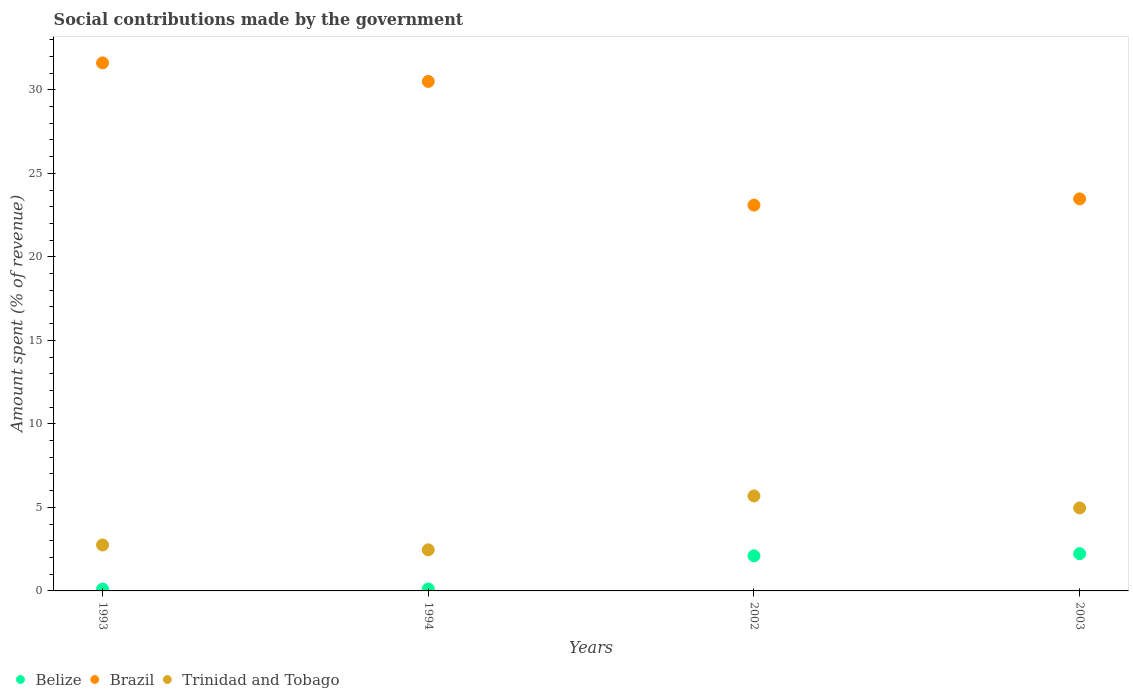Is the number of dotlines equal to the number of legend labels?
Make the answer very short. Yes. What is the amount spent (in %) on social contributions in Trinidad and Tobago in 2003?
Give a very brief answer. 4.97. Across all years, what is the maximum amount spent (in %) on social contributions in Brazil?
Keep it short and to the point. 31.61. Across all years, what is the minimum amount spent (in %) on social contributions in Belize?
Give a very brief answer. 0.11. What is the total amount spent (in %) on social contributions in Belize in the graph?
Offer a terse response. 4.56. What is the difference between the amount spent (in %) on social contributions in Brazil in 1993 and that in 2002?
Your answer should be compact. 8.51. What is the difference between the amount spent (in %) on social contributions in Belize in 1993 and the amount spent (in %) on social contributions in Trinidad and Tobago in 2003?
Offer a terse response. -4.85. What is the average amount spent (in %) on social contributions in Trinidad and Tobago per year?
Make the answer very short. 3.97. In the year 1993, what is the difference between the amount spent (in %) on social contributions in Belize and amount spent (in %) on social contributions in Trinidad and Tobago?
Offer a terse response. -2.64. What is the ratio of the amount spent (in %) on social contributions in Brazil in 2002 to that in 2003?
Your response must be concise. 0.98. What is the difference between the highest and the second highest amount spent (in %) on social contributions in Brazil?
Provide a short and direct response. 1.11. What is the difference between the highest and the lowest amount spent (in %) on social contributions in Brazil?
Offer a very short reply. 8.51. Is the sum of the amount spent (in %) on social contributions in Trinidad and Tobago in 1993 and 1994 greater than the maximum amount spent (in %) on social contributions in Brazil across all years?
Your answer should be very brief. No. Is it the case that in every year, the sum of the amount spent (in %) on social contributions in Trinidad and Tobago and amount spent (in %) on social contributions in Belize  is greater than the amount spent (in %) on social contributions in Brazil?
Your response must be concise. No. Does the amount spent (in %) on social contributions in Trinidad and Tobago monotonically increase over the years?
Offer a terse response. No. Is the amount spent (in %) on social contributions in Trinidad and Tobago strictly greater than the amount spent (in %) on social contributions in Brazil over the years?
Ensure brevity in your answer.  No. Is the amount spent (in %) on social contributions in Belize strictly less than the amount spent (in %) on social contributions in Brazil over the years?
Offer a terse response. Yes. How many dotlines are there?
Provide a succinct answer. 3. How many years are there in the graph?
Offer a very short reply. 4. What is the difference between two consecutive major ticks on the Y-axis?
Give a very brief answer. 5. Does the graph contain grids?
Ensure brevity in your answer.  No. How many legend labels are there?
Ensure brevity in your answer.  3. What is the title of the graph?
Ensure brevity in your answer.  Social contributions made by the government. What is the label or title of the Y-axis?
Offer a terse response. Amount spent (% of revenue). What is the Amount spent (% of revenue) in Belize in 1993?
Ensure brevity in your answer.  0.11. What is the Amount spent (% of revenue) of Brazil in 1993?
Your answer should be compact. 31.61. What is the Amount spent (% of revenue) of Trinidad and Tobago in 1993?
Give a very brief answer. 2.75. What is the Amount spent (% of revenue) in Belize in 1994?
Give a very brief answer. 0.12. What is the Amount spent (% of revenue) of Brazil in 1994?
Ensure brevity in your answer.  30.5. What is the Amount spent (% of revenue) in Trinidad and Tobago in 1994?
Provide a short and direct response. 2.46. What is the Amount spent (% of revenue) in Belize in 2002?
Offer a terse response. 2.1. What is the Amount spent (% of revenue) in Brazil in 2002?
Offer a terse response. 23.1. What is the Amount spent (% of revenue) in Trinidad and Tobago in 2002?
Ensure brevity in your answer.  5.69. What is the Amount spent (% of revenue) in Belize in 2003?
Ensure brevity in your answer.  2.23. What is the Amount spent (% of revenue) in Brazil in 2003?
Provide a short and direct response. 23.47. What is the Amount spent (% of revenue) of Trinidad and Tobago in 2003?
Give a very brief answer. 4.97. Across all years, what is the maximum Amount spent (% of revenue) of Belize?
Your response must be concise. 2.23. Across all years, what is the maximum Amount spent (% of revenue) in Brazil?
Ensure brevity in your answer.  31.61. Across all years, what is the maximum Amount spent (% of revenue) in Trinidad and Tobago?
Offer a very short reply. 5.69. Across all years, what is the minimum Amount spent (% of revenue) in Belize?
Offer a very short reply. 0.11. Across all years, what is the minimum Amount spent (% of revenue) of Brazil?
Your answer should be compact. 23.1. Across all years, what is the minimum Amount spent (% of revenue) of Trinidad and Tobago?
Make the answer very short. 2.46. What is the total Amount spent (% of revenue) of Belize in the graph?
Offer a very short reply. 4.56. What is the total Amount spent (% of revenue) of Brazil in the graph?
Your answer should be very brief. 108.68. What is the total Amount spent (% of revenue) of Trinidad and Tobago in the graph?
Offer a very short reply. 15.86. What is the difference between the Amount spent (% of revenue) of Belize in 1993 and that in 1994?
Make the answer very short. -0.01. What is the difference between the Amount spent (% of revenue) in Brazil in 1993 and that in 1994?
Provide a succinct answer. 1.11. What is the difference between the Amount spent (% of revenue) of Trinidad and Tobago in 1993 and that in 1994?
Offer a very short reply. 0.29. What is the difference between the Amount spent (% of revenue) in Belize in 1993 and that in 2002?
Give a very brief answer. -1.99. What is the difference between the Amount spent (% of revenue) of Brazil in 1993 and that in 2002?
Make the answer very short. 8.51. What is the difference between the Amount spent (% of revenue) of Trinidad and Tobago in 1993 and that in 2002?
Provide a succinct answer. -2.94. What is the difference between the Amount spent (% of revenue) of Belize in 1993 and that in 2003?
Your response must be concise. -2.12. What is the difference between the Amount spent (% of revenue) in Brazil in 1993 and that in 2003?
Offer a terse response. 8.14. What is the difference between the Amount spent (% of revenue) in Trinidad and Tobago in 1993 and that in 2003?
Your answer should be compact. -2.21. What is the difference between the Amount spent (% of revenue) of Belize in 1994 and that in 2002?
Ensure brevity in your answer.  -1.98. What is the difference between the Amount spent (% of revenue) in Brazil in 1994 and that in 2002?
Keep it short and to the point. 7.4. What is the difference between the Amount spent (% of revenue) in Trinidad and Tobago in 1994 and that in 2002?
Make the answer very short. -3.23. What is the difference between the Amount spent (% of revenue) of Belize in 1994 and that in 2003?
Your answer should be very brief. -2.11. What is the difference between the Amount spent (% of revenue) in Brazil in 1994 and that in 2003?
Your answer should be very brief. 7.03. What is the difference between the Amount spent (% of revenue) in Trinidad and Tobago in 1994 and that in 2003?
Ensure brevity in your answer.  -2.51. What is the difference between the Amount spent (% of revenue) in Belize in 2002 and that in 2003?
Keep it short and to the point. -0.13. What is the difference between the Amount spent (% of revenue) in Brazil in 2002 and that in 2003?
Give a very brief answer. -0.37. What is the difference between the Amount spent (% of revenue) of Trinidad and Tobago in 2002 and that in 2003?
Offer a very short reply. 0.72. What is the difference between the Amount spent (% of revenue) in Belize in 1993 and the Amount spent (% of revenue) in Brazil in 1994?
Your answer should be very brief. -30.39. What is the difference between the Amount spent (% of revenue) of Belize in 1993 and the Amount spent (% of revenue) of Trinidad and Tobago in 1994?
Your answer should be compact. -2.35. What is the difference between the Amount spent (% of revenue) in Brazil in 1993 and the Amount spent (% of revenue) in Trinidad and Tobago in 1994?
Keep it short and to the point. 29.15. What is the difference between the Amount spent (% of revenue) of Belize in 1993 and the Amount spent (% of revenue) of Brazil in 2002?
Offer a very short reply. -22.98. What is the difference between the Amount spent (% of revenue) of Belize in 1993 and the Amount spent (% of revenue) of Trinidad and Tobago in 2002?
Give a very brief answer. -5.58. What is the difference between the Amount spent (% of revenue) in Brazil in 1993 and the Amount spent (% of revenue) in Trinidad and Tobago in 2002?
Provide a succinct answer. 25.92. What is the difference between the Amount spent (% of revenue) of Belize in 1993 and the Amount spent (% of revenue) of Brazil in 2003?
Ensure brevity in your answer.  -23.36. What is the difference between the Amount spent (% of revenue) in Belize in 1993 and the Amount spent (% of revenue) in Trinidad and Tobago in 2003?
Offer a very short reply. -4.86. What is the difference between the Amount spent (% of revenue) in Brazil in 1993 and the Amount spent (% of revenue) in Trinidad and Tobago in 2003?
Give a very brief answer. 26.64. What is the difference between the Amount spent (% of revenue) in Belize in 1994 and the Amount spent (% of revenue) in Brazil in 2002?
Make the answer very short. -22.98. What is the difference between the Amount spent (% of revenue) in Belize in 1994 and the Amount spent (% of revenue) in Trinidad and Tobago in 2002?
Offer a terse response. -5.57. What is the difference between the Amount spent (% of revenue) in Brazil in 1994 and the Amount spent (% of revenue) in Trinidad and Tobago in 2002?
Offer a very short reply. 24.81. What is the difference between the Amount spent (% of revenue) of Belize in 1994 and the Amount spent (% of revenue) of Brazil in 2003?
Give a very brief answer. -23.35. What is the difference between the Amount spent (% of revenue) in Belize in 1994 and the Amount spent (% of revenue) in Trinidad and Tobago in 2003?
Provide a short and direct response. -4.85. What is the difference between the Amount spent (% of revenue) of Brazil in 1994 and the Amount spent (% of revenue) of Trinidad and Tobago in 2003?
Keep it short and to the point. 25.53. What is the difference between the Amount spent (% of revenue) of Belize in 2002 and the Amount spent (% of revenue) of Brazil in 2003?
Give a very brief answer. -21.37. What is the difference between the Amount spent (% of revenue) of Belize in 2002 and the Amount spent (% of revenue) of Trinidad and Tobago in 2003?
Your response must be concise. -2.87. What is the difference between the Amount spent (% of revenue) in Brazil in 2002 and the Amount spent (% of revenue) in Trinidad and Tobago in 2003?
Provide a succinct answer. 18.13. What is the average Amount spent (% of revenue) of Belize per year?
Give a very brief answer. 1.14. What is the average Amount spent (% of revenue) in Brazil per year?
Provide a succinct answer. 27.17. What is the average Amount spent (% of revenue) in Trinidad and Tobago per year?
Your answer should be very brief. 3.97. In the year 1993, what is the difference between the Amount spent (% of revenue) in Belize and Amount spent (% of revenue) in Brazil?
Your answer should be very brief. -31.5. In the year 1993, what is the difference between the Amount spent (% of revenue) in Belize and Amount spent (% of revenue) in Trinidad and Tobago?
Provide a short and direct response. -2.64. In the year 1993, what is the difference between the Amount spent (% of revenue) of Brazil and Amount spent (% of revenue) of Trinidad and Tobago?
Your response must be concise. 28.86. In the year 1994, what is the difference between the Amount spent (% of revenue) of Belize and Amount spent (% of revenue) of Brazil?
Your response must be concise. -30.38. In the year 1994, what is the difference between the Amount spent (% of revenue) in Belize and Amount spent (% of revenue) in Trinidad and Tobago?
Provide a short and direct response. -2.34. In the year 1994, what is the difference between the Amount spent (% of revenue) in Brazil and Amount spent (% of revenue) in Trinidad and Tobago?
Provide a succinct answer. 28.04. In the year 2002, what is the difference between the Amount spent (% of revenue) in Belize and Amount spent (% of revenue) in Brazil?
Make the answer very short. -21. In the year 2002, what is the difference between the Amount spent (% of revenue) of Belize and Amount spent (% of revenue) of Trinidad and Tobago?
Your answer should be very brief. -3.59. In the year 2002, what is the difference between the Amount spent (% of revenue) of Brazil and Amount spent (% of revenue) of Trinidad and Tobago?
Give a very brief answer. 17.41. In the year 2003, what is the difference between the Amount spent (% of revenue) in Belize and Amount spent (% of revenue) in Brazil?
Provide a short and direct response. -21.24. In the year 2003, what is the difference between the Amount spent (% of revenue) in Belize and Amount spent (% of revenue) in Trinidad and Tobago?
Your answer should be very brief. -2.74. In the year 2003, what is the difference between the Amount spent (% of revenue) in Brazil and Amount spent (% of revenue) in Trinidad and Tobago?
Give a very brief answer. 18.5. What is the ratio of the Amount spent (% of revenue) of Belize in 1993 to that in 1994?
Make the answer very short. 0.94. What is the ratio of the Amount spent (% of revenue) in Brazil in 1993 to that in 1994?
Your answer should be very brief. 1.04. What is the ratio of the Amount spent (% of revenue) of Trinidad and Tobago in 1993 to that in 1994?
Keep it short and to the point. 1.12. What is the ratio of the Amount spent (% of revenue) of Belize in 1993 to that in 2002?
Your answer should be very brief. 0.05. What is the ratio of the Amount spent (% of revenue) of Brazil in 1993 to that in 2002?
Ensure brevity in your answer.  1.37. What is the ratio of the Amount spent (% of revenue) in Trinidad and Tobago in 1993 to that in 2002?
Your answer should be very brief. 0.48. What is the ratio of the Amount spent (% of revenue) of Belize in 1993 to that in 2003?
Make the answer very short. 0.05. What is the ratio of the Amount spent (% of revenue) in Brazil in 1993 to that in 2003?
Give a very brief answer. 1.35. What is the ratio of the Amount spent (% of revenue) in Trinidad and Tobago in 1993 to that in 2003?
Provide a succinct answer. 0.55. What is the ratio of the Amount spent (% of revenue) in Belize in 1994 to that in 2002?
Provide a short and direct response. 0.06. What is the ratio of the Amount spent (% of revenue) of Brazil in 1994 to that in 2002?
Make the answer very short. 1.32. What is the ratio of the Amount spent (% of revenue) in Trinidad and Tobago in 1994 to that in 2002?
Your response must be concise. 0.43. What is the ratio of the Amount spent (% of revenue) of Belize in 1994 to that in 2003?
Provide a succinct answer. 0.05. What is the ratio of the Amount spent (% of revenue) of Brazil in 1994 to that in 2003?
Your response must be concise. 1.3. What is the ratio of the Amount spent (% of revenue) in Trinidad and Tobago in 1994 to that in 2003?
Provide a succinct answer. 0.5. What is the ratio of the Amount spent (% of revenue) in Belize in 2002 to that in 2003?
Your answer should be very brief. 0.94. What is the ratio of the Amount spent (% of revenue) of Brazil in 2002 to that in 2003?
Provide a short and direct response. 0.98. What is the ratio of the Amount spent (% of revenue) of Trinidad and Tobago in 2002 to that in 2003?
Provide a succinct answer. 1.15. What is the difference between the highest and the second highest Amount spent (% of revenue) in Belize?
Give a very brief answer. 0.13. What is the difference between the highest and the second highest Amount spent (% of revenue) in Brazil?
Your response must be concise. 1.11. What is the difference between the highest and the second highest Amount spent (% of revenue) of Trinidad and Tobago?
Your response must be concise. 0.72. What is the difference between the highest and the lowest Amount spent (% of revenue) in Belize?
Your answer should be compact. 2.12. What is the difference between the highest and the lowest Amount spent (% of revenue) in Brazil?
Offer a very short reply. 8.51. What is the difference between the highest and the lowest Amount spent (% of revenue) of Trinidad and Tobago?
Your response must be concise. 3.23. 